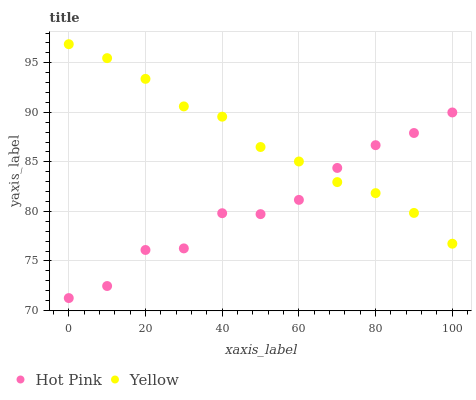Does Hot Pink have the minimum area under the curve?
Answer yes or no. Yes. Does Yellow have the maximum area under the curve?
Answer yes or no. Yes. Does Yellow have the minimum area under the curve?
Answer yes or no. No. Is Yellow the smoothest?
Answer yes or no. Yes. Is Hot Pink the roughest?
Answer yes or no. Yes. Is Yellow the roughest?
Answer yes or no. No. Does Hot Pink have the lowest value?
Answer yes or no. Yes. Does Yellow have the lowest value?
Answer yes or no. No. Does Yellow have the highest value?
Answer yes or no. Yes. Does Yellow intersect Hot Pink?
Answer yes or no. Yes. Is Yellow less than Hot Pink?
Answer yes or no. No. Is Yellow greater than Hot Pink?
Answer yes or no. No. 